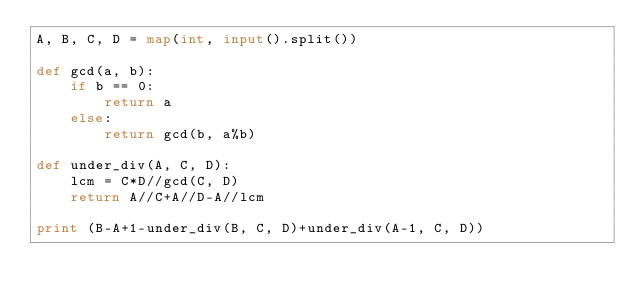Convert code to text. <code><loc_0><loc_0><loc_500><loc_500><_Python_>A, B, C, D = map(int, input().split())

def gcd(a, b):
    if b == 0:
        return a
    else:
        return gcd(b, a%b)

def under_div(A, C, D):
    lcm = C*D//gcd(C, D)
    return A//C+A//D-A//lcm

print (B-A+1-under_div(B, C, D)+under_div(A-1, C, D))</code> 